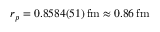<formula> <loc_0><loc_0><loc_500><loc_500>r _ { p } = 0 . 8 5 8 4 ( 5 1 ) \, f m \approx 0 . 8 6 \, f m</formula> 